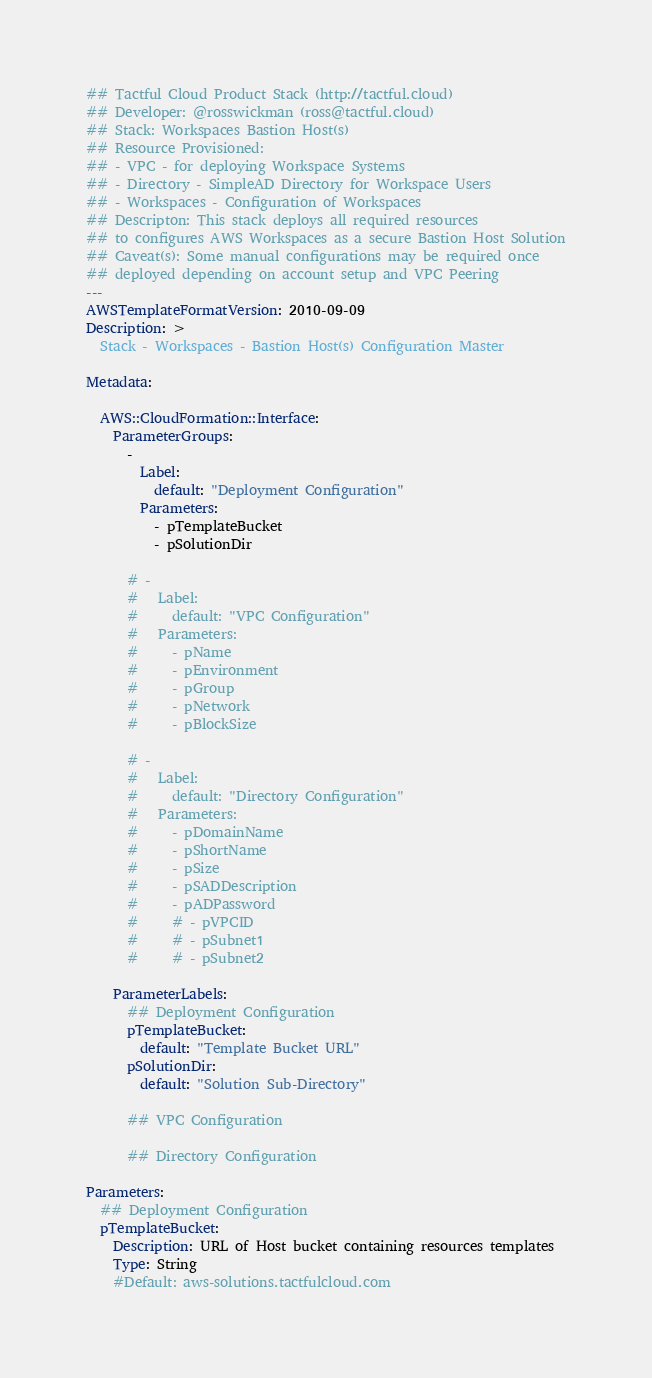Convert code to text. <code><loc_0><loc_0><loc_500><loc_500><_YAML_>## Tactful Cloud Product Stack (http://tactful.cloud)
## Developer: @rosswickman (ross@tactful.cloud)
## Stack: Workspaces Bastion Host(s)
## Resource Provisioned:
## - VPC - for deploying Workspace Systems
## - Directory - SimpleAD Directory for Workspace Users
## - Workspaces - Configuration of Workspaces
## Descripton: This stack deploys all required resources
## to configures AWS Workspaces as a secure Bastion Host Solution
## Caveat(s): Some manual configurations may be required once
## deployed depending on account setup and VPC Peering
---
AWSTemplateFormatVersion: 2010-09-09
Description: >
  Stack - Workspaces - Bastion Host(s) Configuration Master

Metadata:

  AWS::CloudFormation::Interface:
    ParameterGroups:
      - 
        Label:
          default: "Deployment Configuration"
        Parameters:
          - pTemplateBucket
          - pSolutionDir

      # - 
      #   Label:
      #     default: "VPC Configuration"
      #   Parameters:
      #     - pName
      #     - pEnvironment
      #     - pGroup
      #     - pNetwork
      #     - pBlockSize

      # - 
      #   Label:
      #     default: "Directory Configuration"
      #   Parameters:
      #     - pDomainName
      #     - pShortName
      #     - pSize
      #     - pSADDescription
      #     - pADPassword
      #     # - pVPCID
      #     # - pSubnet1
      #     # - pSubnet2

    ParameterLabels:
      ## Deployment Configuration
      pTemplateBucket:
        default: "Template Bucket URL"
      pSolutionDir:
        default: "Solution Sub-Directory"

      ## VPC Configuration

      ## Directory Configuration

Parameters:
  ## Deployment Configuration
  pTemplateBucket:
    Description: URL of Host bucket containing resources templates
    Type: String
    #Default: aws-solutions.tactfulcloud.com</code> 